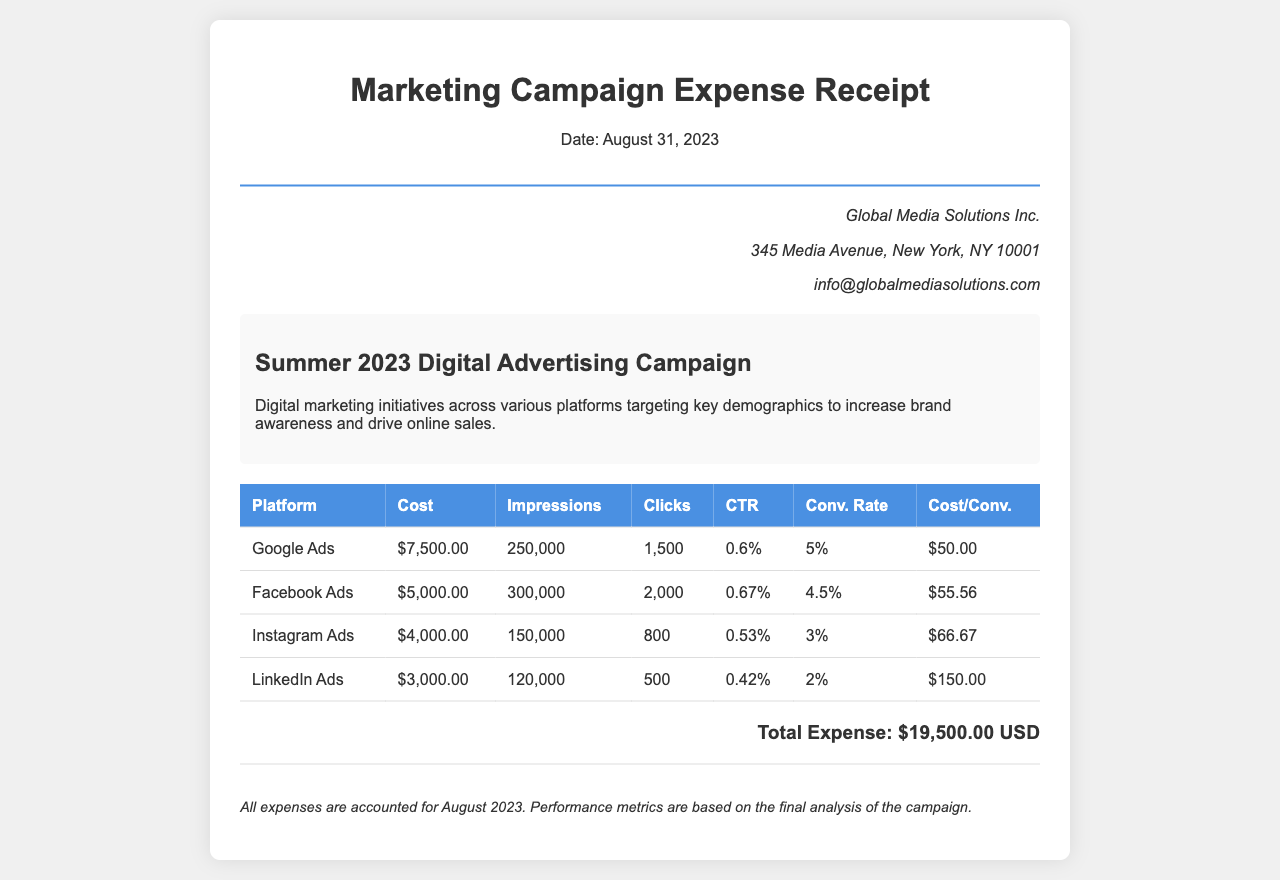what is the total expense? The total expense is provided at the bottom of the document, which sums all the individual platform costs.
Answer: $19,500.00 USD what is the date of the receipt? The date of the receipt is mentioned in the header section of the document.
Answer: August 31, 2023 which platform had the highest cost? The highest cost platform is listed in the table of expenses for each platform.
Answer: Google Ads what is the CTR for Facebook Ads? The CTR (Click-Through Rate) for Facebook Ads is stated in the metrics column of the table.
Answer: 0.67% what is the conversion rate for Instagram Ads? The conversion rate for Instagram Ads is specified in the table under the respective column.
Answer: 3% how many impressions did LinkedIn Ads receive? The number of impressions for LinkedIn Ads is shown in the respective table row.
Answer: 120,000 what is the cost per conversion for Google Ads? The cost per conversion for Google Ads is provided in the performance metrics section of the table.
Answer: $50.00 which platform had the lowest conversion rate? The lowest conversion rate can be determined by comparing the values in the table.
Answer: LinkedIn Ads 